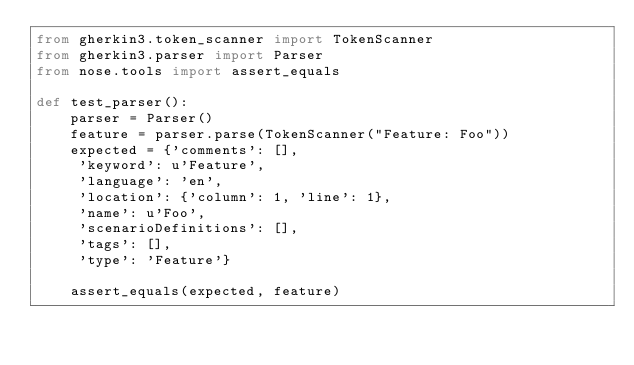Convert code to text. <code><loc_0><loc_0><loc_500><loc_500><_Python_>from gherkin3.token_scanner import TokenScanner
from gherkin3.parser import Parser
from nose.tools import assert_equals

def test_parser():
    parser = Parser()
    feature = parser.parse(TokenScanner("Feature: Foo"))
    expected = {'comments': [],
     'keyword': u'Feature',
     'language': 'en',
     'location': {'column': 1, 'line': 1},
     'name': u'Foo',
     'scenarioDefinitions': [],
     'tags': [],
     'type': 'Feature'}

    assert_equals(expected, feature)
</code> 